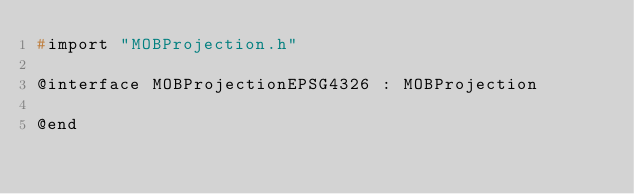Convert code to text. <code><loc_0><loc_0><loc_500><loc_500><_C_>#import "MOBProjection.h"

@interface MOBProjectionEPSG4326 : MOBProjection

@end
</code> 